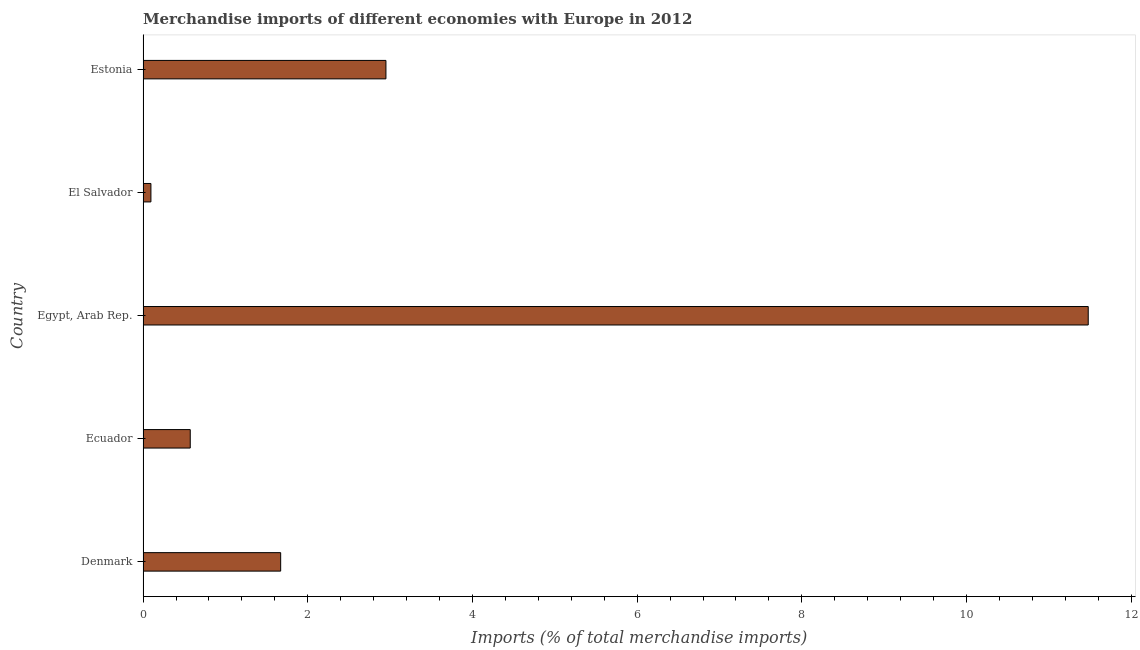Does the graph contain grids?
Your response must be concise. No. What is the title of the graph?
Give a very brief answer. Merchandise imports of different economies with Europe in 2012. What is the label or title of the X-axis?
Make the answer very short. Imports (% of total merchandise imports). What is the merchandise imports in Denmark?
Provide a succinct answer. 1.67. Across all countries, what is the maximum merchandise imports?
Give a very brief answer. 11.48. Across all countries, what is the minimum merchandise imports?
Your response must be concise. 0.1. In which country was the merchandise imports maximum?
Give a very brief answer. Egypt, Arab Rep. In which country was the merchandise imports minimum?
Make the answer very short. El Salvador. What is the sum of the merchandise imports?
Your answer should be compact. 16.77. What is the difference between the merchandise imports in Denmark and Egypt, Arab Rep.?
Ensure brevity in your answer.  -9.81. What is the average merchandise imports per country?
Offer a very short reply. 3.35. What is the median merchandise imports?
Give a very brief answer. 1.67. In how many countries, is the merchandise imports greater than 4.8 %?
Make the answer very short. 1. What is the ratio of the merchandise imports in Denmark to that in Ecuador?
Your response must be concise. 2.92. Is the merchandise imports in Ecuador less than that in Egypt, Arab Rep.?
Your answer should be very brief. Yes. What is the difference between the highest and the second highest merchandise imports?
Provide a succinct answer. 8.53. Is the sum of the merchandise imports in Ecuador and Egypt, Arab Rep. greater than the maximum merchandise imports across all countries?
Your answer should be compact. Yes. What is the difference between the highest and the lowest merchandise imports?
Give a very brief answer. 11.38. In how many countries, is the merchandise imports greater than the average merchandise imports taken over all countries?
Provide a short and direct response. 1. Are all the bars in the graph horizontal?
Make the answer very short. Yes. What is the Imports (% of total merchandise imports) in Denmark?
Provide a short and direct response. 1.67. What is the Imports (% of total merchandise imports) of Ecuador?
Your response must be concise. 0.57. What is the Imports (% of total merchandise imports) in Egypt, Arab Rep.?
Give a very brief answer. 11.48. What is the Imports (% of total merchandise imports) of El Salvador?
Ensure brevity in your answer.  0.1. What is the Imports (% of total merchandise imports) of Estonia?
Your answer should be compact. 2.95. What is the difference between the Imports (% of total merchandise imports) in Denmark and Ecuador?
Provide a succinct answer. 1.1. What is the difference between the Imports (% of total merchandise imports) in Denmark and Egypt, Arab Rep.?
Ensure brevity in your answer.  -9.81. What is the difference between the Imports (% of total merchandise imports) in Denmark and El Salvador?
Give a very brief answer. 1.58. What is the difference between the Imports (% of total merchandise imports) in Denmark and Estonia?
Provide a short and direct response. -1.28. What is the difference between the Imports (% of total merchandise imports) in Ecuador and Egypt, Arab Rep.?
Provide a short and direct response. -10.9. What is the difference between the Imports (% of total merchandise imports) in Ecuador and El Salvador?
Your response must be concise. 0.48. What is the difference between the Imports (% of total merchandise imports) in Ecuador and Estonia?
Provide a succinct answer. -2.38. What is the difference between the Imports (% of total merchandise imports) in Egypt, Arab Rep. and El Salvador?
Make the answer very short. 11.38. What is the difference between the Imports (% of total merchandise imports) in Egypt, Arab Rep. and Estonia?
Give a very brief answer. 8.53. What is the difference between the Imports (% of total merchandise imports) in El Salvador and Estonia?
Your answer should be compact. -2.85. What is the ratio of the Imports (% of total merchandise imports) in Denmark to that in Ecuador?
Keep it short and to the point. 2.92. What is the ratio of the Imports (% of total merchandise imports) in Denmark to that in Egypt, Arab Rep.?
Offer a very short reply. 0.15. What is the ratio of the Imports (% of total merchandise imports) in Denmark to that in El Salvador?
Offer a terse response. 17.53. What is the ratio of the Imports (% of total merchandise imports) in Denmark to that in Estonia?
Keep it short and to the point. 0.57. What is the ratio of the Imports (% of total merchandise imports) in Ecuador to that in Egypt, Arab Rep.?
Make the answer very short. 0.05. What is the ratio of the Imports (% of total merchandise imports) in Ecuador to that in El Salvador?
Give a very brief answer. 6.01. What is the ratio of the Imports (% of total merchandise imports) in Ecuador to that in Estonia?
Provide a succinct answer. 0.19. What is the ratio of the Imports (% of total merchandise imports) in Egypt, Arab Rep. to that in El Salvador?
Your response must be concise. 120.38. What is the ratio of the Imports (% of total merchandise imports) in Egypt, Arab Rep. to that in Estonia?
Provide a short and direct response. 3.89. What is the ratio of the Imports (% of total merchandise imports) in El Salvador to that in Estonia?
Your answer should be very brief. 0.03. 